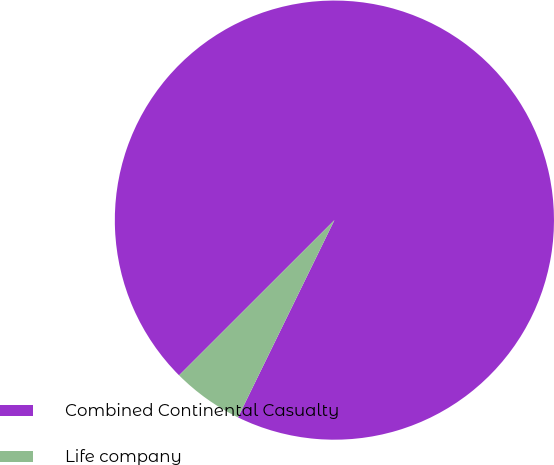Convert chart. <chart><loc_0><loc_0><loc_500><loc_500><pie_chart><fcel>Combined Continental Casualty<fcel>Life company<nl><fcel>94.73%<fcel>5.27%<nl></chart> 